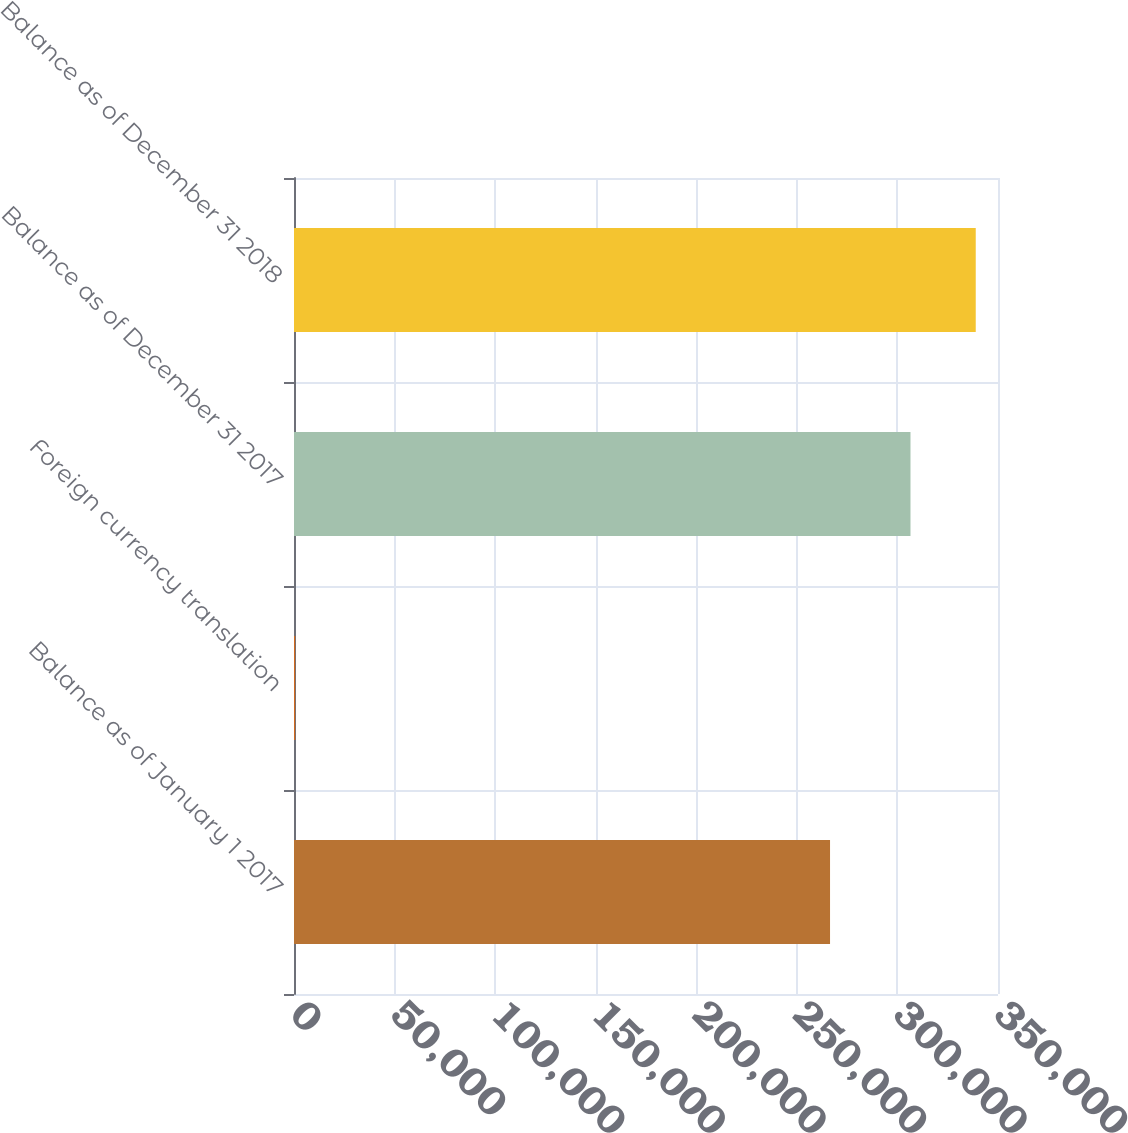Convert chart. <chart><loc_0><loc_0><loc_500><loc_500><bar_chart><fcel>Balance as of January 1 2017<fcel>Foreign currency translation<fcel>Balance as of December 31 2017<fcel>Balance as of December 31 2018<nl><fcel>266495<fcel>577<fcel>306491<fcel>338933<nl></chart> 